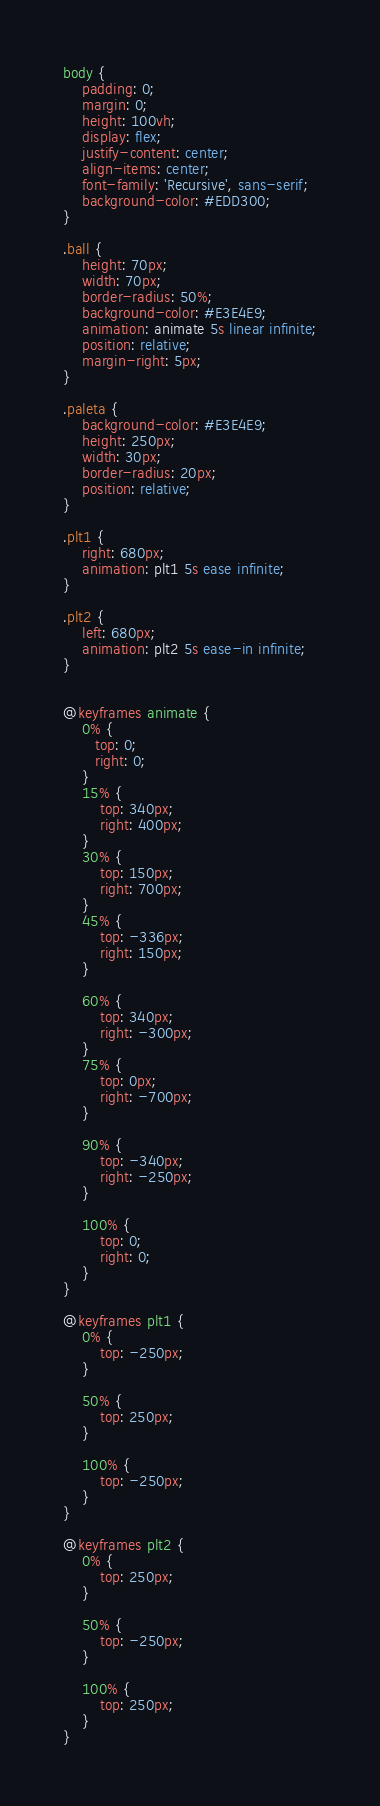Convert code to text. <code><loc_0><loc_0><loc_500><loc_500><_CSS_>body {
    padding: 0;
    margin: 0;
    height: 100vh;
    display: flex;
    justify-content: center;
    align-items: center;
    font-family: 'Recursive', sans-serif;
    background-color: #EDD300;
}

.ball {
    height: 70px;
    width: 70px;
    border-radius: 50%;
    background-color: #E3E4E9;
    animation: animate 5s linear infinite;
    position: relative;
    margin-right: 5px;
}

.paleta {
    background-color: #E3E4E9;
    height: 250px;
    width: 30px;
    border-radius: 20px;
    position: relative;
}

.plt1 {
    right: 680px;
    animation: plt1 5s ease infinite;
}

.plt2 {
    left: 680px;
    animation: plt2 5s ease-in infinite;
}


@keyframes animate {
    0% {
       top: 0;
       right: 0;
    }
    15% {
        top: 340px;
        right: 400px;
    }
    30% {
        top: 150px;
        right: 700px;
    }
    45% {
        top: -336px;
        right: 150px;
    }

    60% {
        top: 340px;
        right: -300px;
    }
    75% {
        top: 0px;
        right: -700px;
    }

    90% {
        top: -340px;
        right: -250px;
    }

    100% {
        top: 0;
        right: 0;
    }
}

@keyframes plt1 {
    0% {
        top: -250px;
    }

    50% {
        top: 250px;
    }
    
    100% {
        top: -250px;
    }
}

@keyframes plt2 {
    0% {
        top: 250px;
    }

    50% {
        top: -250px;
    }
    
    100% {
        top: 250px;
    }
}


</code> 